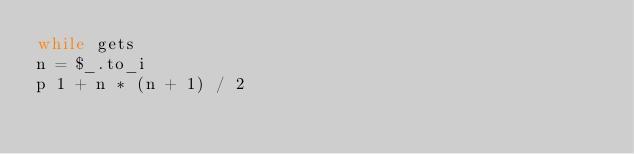<code> <loc_0><loc_0><loc_500><loc_500><_Ruby_>while gets
n = $_.to_i
p 1 + n * (n + 1) / 2</code> 